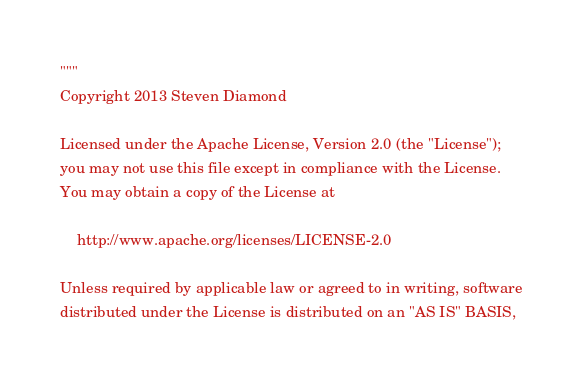<code> <loc_0><loc_0><loc_500><loc_500><_Python_>"""
Copyright 2013 Steven Diamond

Licensed under the Apache License, Version 2.0 (the "License");
you may not use this file except in compliance with the License.
You may obtain a copy of the License at

    http://www.apache.org/licenses/LICENSE-2.0

Unless required by applicable law or agreed to in writing, software
distributed under the License is distributed on an "AS IS" BASIS,</code> 